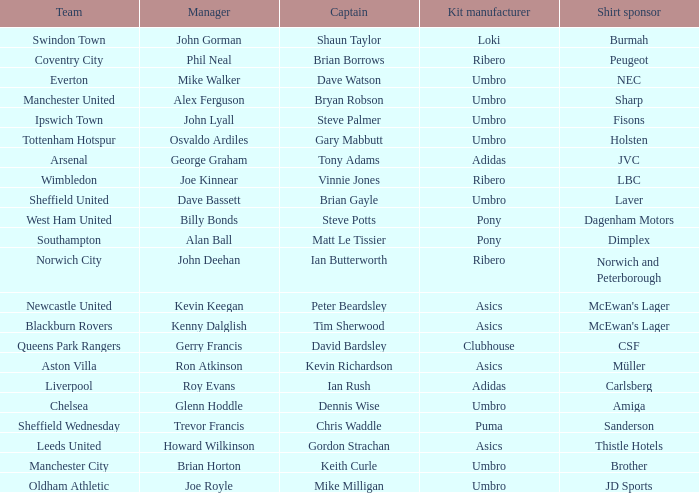Which captain has howard wilkinson as the manager? Gordon Strachan. 